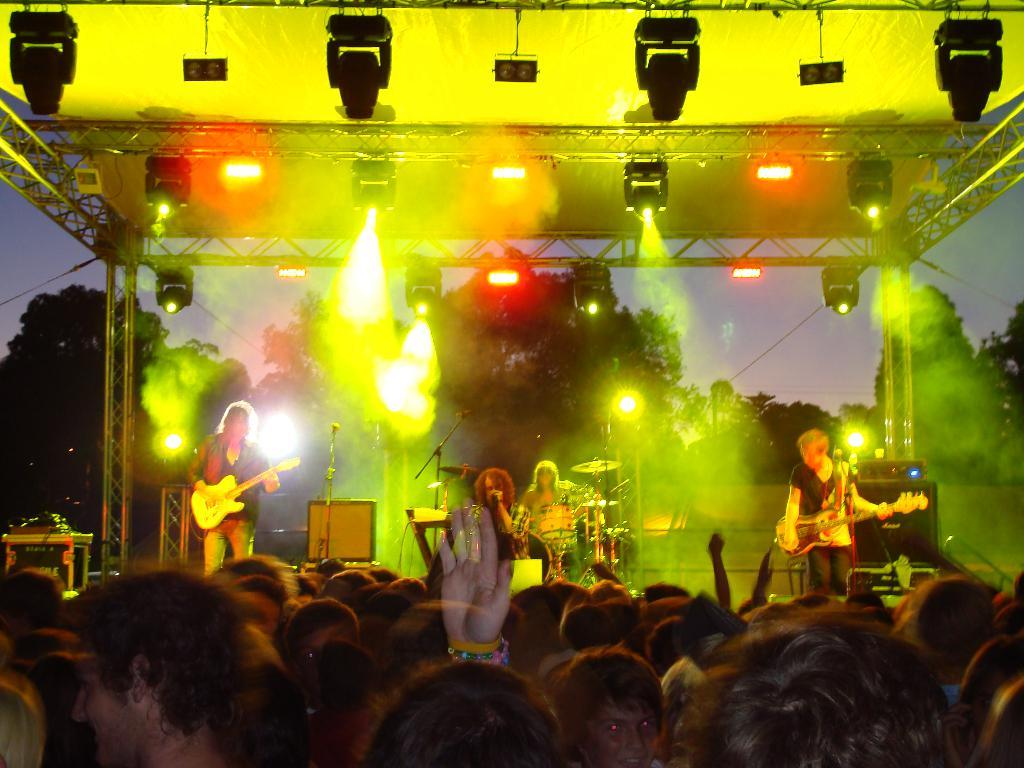What are the people in the image doing? The people in the image are playing musical instruments on a stage. What can be seen above the stage? There are lights attached at the top of the stage. Can you describe the people visible in the image? Yes, there are people visible in the image. What type of natural elements can be seen in the image? There are trees in the image. What is the weight of the worm crawling on the businessman's desk in the image? There is no worm or businessman's desk present in the image. 